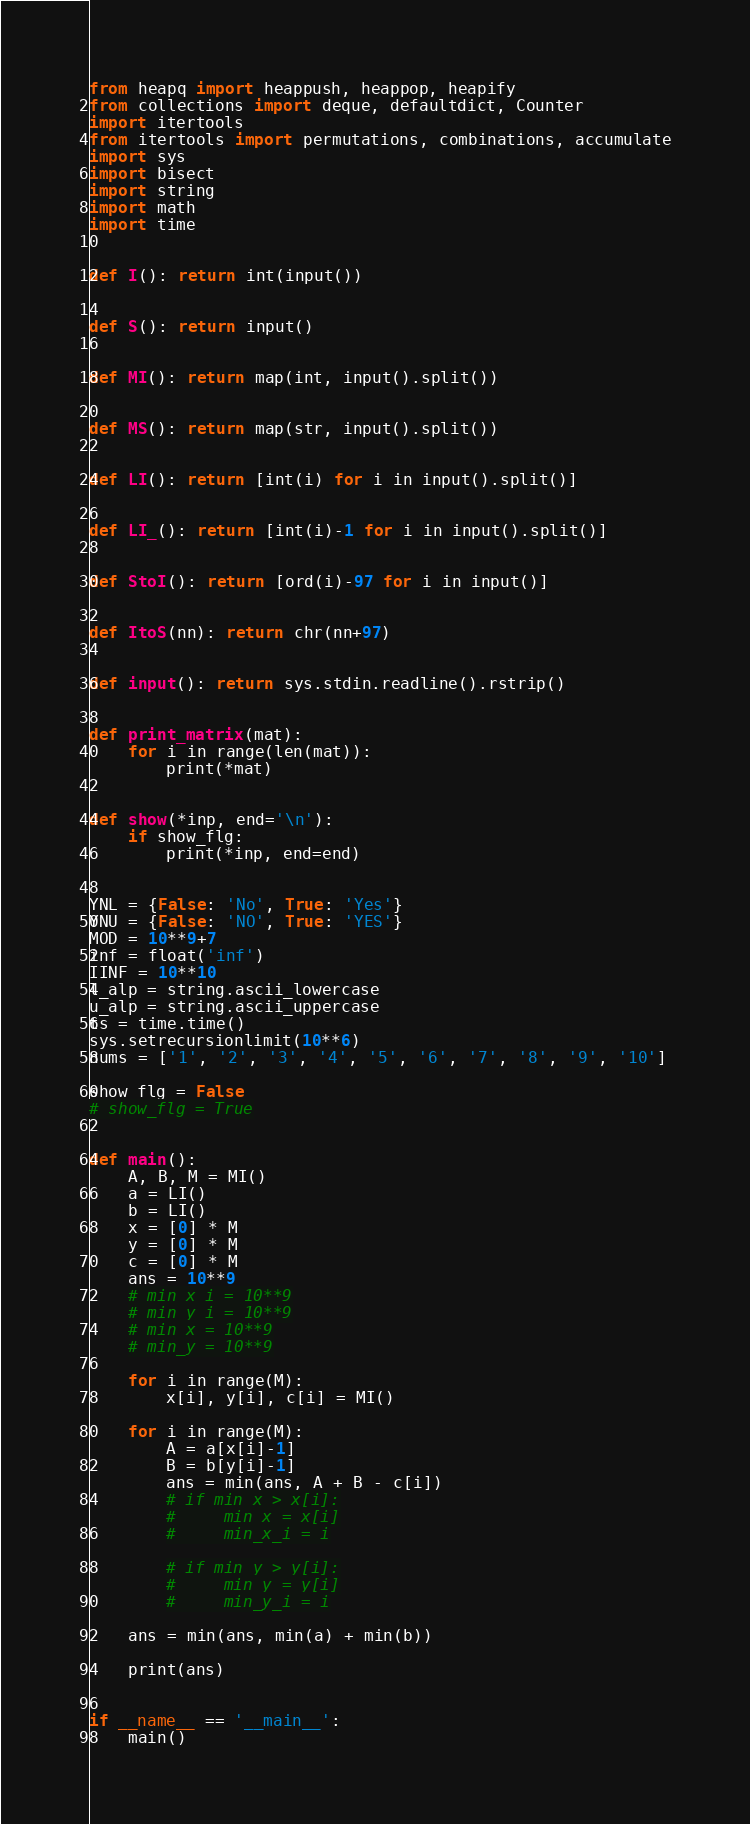Convert code to text. <code><loc_0><loc_0><loc_500><loc_500><_Python_>from heapq import heappush, heappop, heapify
from collections import deque, defaultdict, Counter
import itertools
from itertools import permutations, combinations, accumulate
import sys
import bisect
import string
import math
import time


def I(): return int(input())


def S(): return input()


def MI(): return map(int, input().split())


def MS(): return map(str, input().split())


def LI(): return [int(i) for i in input().split()]


def LI_(): return [int(i)-1 for i in input().split()]


def StoI(): return [ord(i)-97 for i in input()]


def ItoS(nn): return chr(nn+97)


def input(): return sys.stdin.readline().rstrip()


def print_matrix(mat):
    for i in range(len(mat)):
        print(*mat)


def show(*inp, end='\n'):
    if show_flg:
        print(*inp, end=end)


YNL = {False: 'No', True: 'Yes'}
YNU = {False: 'NO', True: 'YES'}
MOD = 10**9+7
inf = float('inf')
IINF = 10**10
l_alp = string.ascii_lowercase
u_alp = string.ascii_uppercase
ts = time.time()
sys.setrecursionlimit(10**6)
nums = ['1', '2', '3', '4', '5', '6', '7', '8', '9', '10']

show_flg = False
# show_flg = True


def main():
    A, B, M = MI()
    a = LI()
    b = LI()
    x = [0] * M
    y = [0] * M
    c = [0] * M
    ans = 10**9
    # min_x_i = 10**9
    # min_y_i = 10**9
    # min_x = 10**9
    # min_y = 10**9

    for i in range(M):
        x[i], y[i], c[i] = MI()

    for i in range(M):
        A = a[x[i]-1]
        B = b[y[i]-1]
        ans = min(ans, A + B - c[i])
        # if min_x > x[i]:
        #     min_x = x[i]
        #     min_x_i = i

        # if min_y > y[i]:
        #     min_y = y[i]
        #     min_y_i = i

    ans = min(ans, min(a) + min(b))

    print(ans)


if __name__ == '__main__':
    main()
</code> 